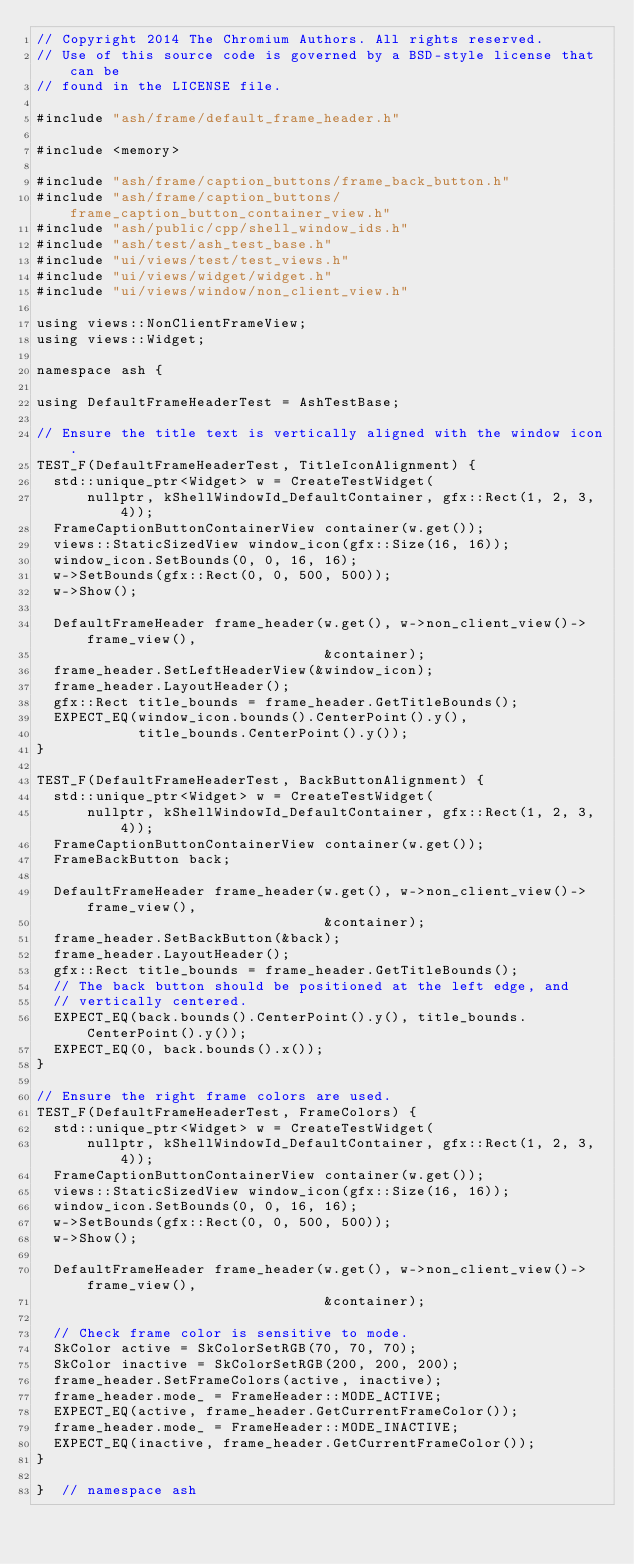<code> <loc_0><loc_0><loc_500><loc_500><_C++_>// Copyright 2014 The Chromium Authors. All rights reserved.
// Use of this source code is governed by a BSD-style license that can be
// found in the LICENSE file.

#include "ash/frame/default_frame_header.h"

#include <memory>

#include "ash/frame/caption_buttons/frame_back_button.h"
#include "ash/frame/caption_buttons/frame_caption_button_container_view.h"
#include "ash/public/cpp/shell_window_ids.h"
#include "ash/test/ash_test_base.h"
#include "ui/views/test/test_views.h"
#include "ui/views/widget/widget.h"
#include "ui/views/window/non_client_view.h"

using views::NonClientFrameView;
using views::Widget;

namespace ash {

using DefaultFrameHeaderTest = AshTestBase;

// Ensure the title text is vertically aligned with the window icon.
TEST_F(DefaultFrameHeaderTest, TitleIconAlignment) {
  std::unique_ptr<Widget> w = CreateTestWidget(
      nullptr, kShellWindowId_DefaultContainer, gfx::Rect(1, 2, 3, 4));
  FrameCaptionButtonContainerView container(w.get());
  views::StaticSizedView window_icon(gfx::Size(16, 16));
  window_icon.SetBounds(0, 0, 16, 16);
  w->SetBounds(gfx::Rect(0, 0, 500, 500));
  w->Show();

  DefaultFrameHeader frame_header(w.get(), w->non_client_view()->frame_view(),
                                  &container);
  frame_header.SetLeftHeaderView(&window_icon);
  frame_header.LayoutHeader();
  gfx::Rect title_bounds = frame_header.GetTitleBounds();
  EXPECT_EQ(window_icon.bounds().CenterPoint().y(),
            title_bounds.CenterPoint().y());
}

TEST_F(DefaultFrameHeaderTest, BackButtonAlignment) {
  std::unique_ptr<Widget> w = CreateTestWidget(
      nullptr, kShellWindowId_DefaultContainer, gfx::Rect(1, 2, 3, 4));
  FrameCaptionButtonContainerView container(w.get());
  FrameBackButton back;

  DefaultFrameHeader frame_header(w.get(), w->non_client_view()->frame_view(),
                                  &container);
  frame_header.SetBackButton(&back);
  frame_header.LayoutHeader();
  gfx::Rect title_bounds = frame_header.GetTitleBounds();
  // The back button should be positioned at the left edge, and
  // vertically centered.
  EXPECT_EQ(back.bounds().CenterPoint().y(), title_bounds.CenterPoint().y());
  EXPECT_EQ(0, back.bounds().x());
}

// Ensure the right frame colors are used.
TEST_F(DefaultFrameHeaderTest, FrameColors) {
  std::unique_ptr<Widget> w = CreateTestWidget(
      nullptr, kShellWindowId_DefaultContainer, gfx::Rect(1, 2, 3, 4));
  FrameCaptionButtonContainerView container(w.get());
  views::StaticSizedView window_icon(gfx::Size(16, 16));
  window_icon.SetBounds(0, 0, 16, 16);
  w->SetBounds(gfx::Rect(0, 0, 500, 500));
  w->Show();

  DefaultFrameHeader frame_header(w.get(), w->non_client_view()->frame_view(),
                                  &container);

  // Check frame color is sensitive to mode.
  SkColor active = SkColorSetRGB(70, 70, 70);
  SkColor inactive = SkColorSetRGB(200, 200, 200);
  frame_header.SetFrameColors(active, inactive);
  frame_header.mode_ = FrameHeader::MODE_ACTIVE;
  EXPECT_EQ(active, frame_header.GetCurrentFrameColor());
  frame_header.mode_ = FrameHeader::MODE_INACTIVE;
  EXPECT_EQ(inactive, frame_header.GetCurrentFrameColor());
}

}  // namespace ash
</code> 